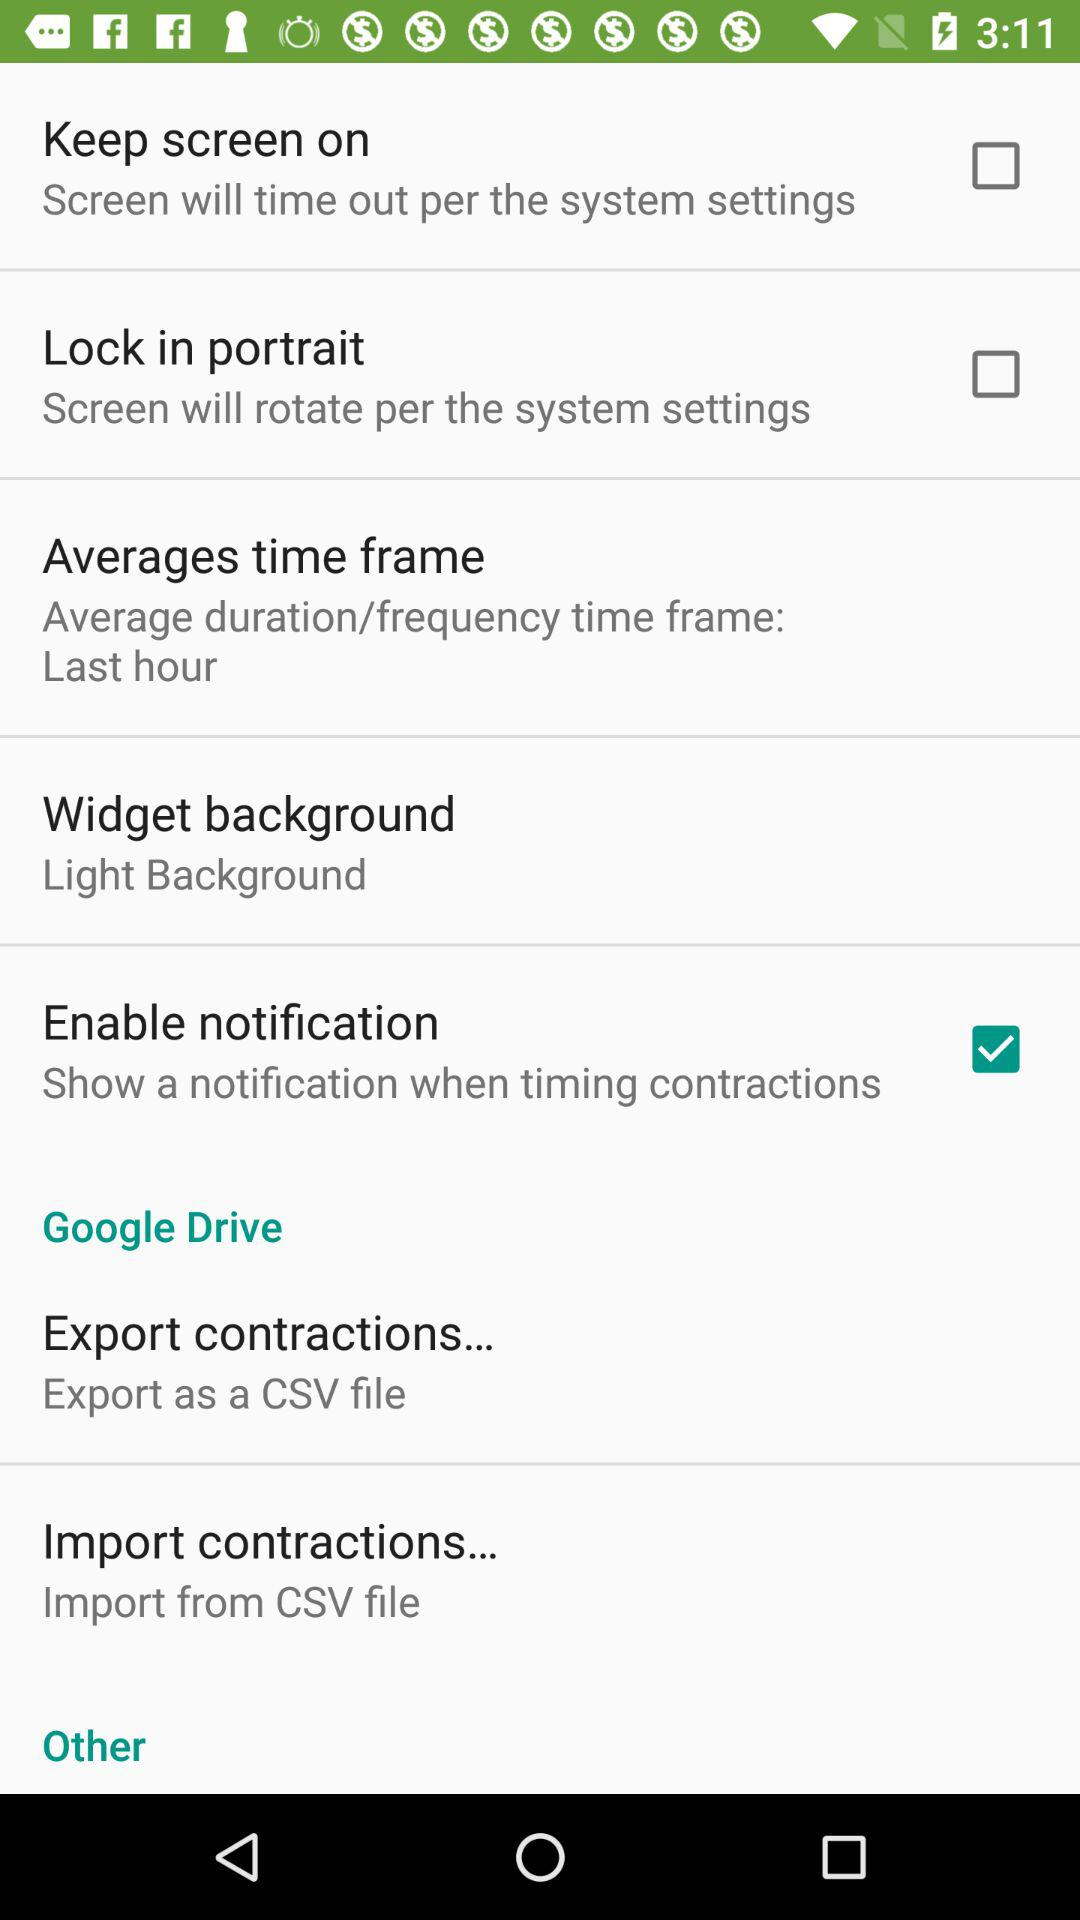Is "Lock in portrait" enabled or disabled? "Lock in portrait" is disabled. 